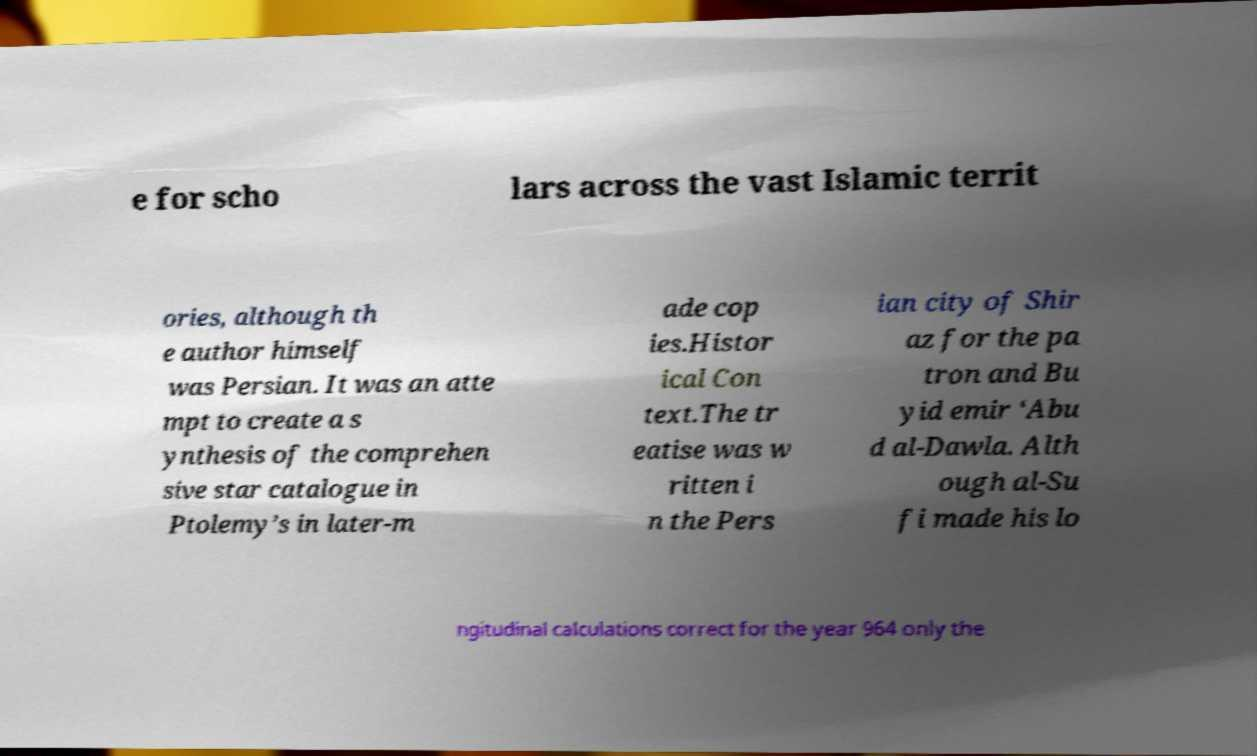There's text embedded in this image that I need extracted. Can you transcribe it verbatim? e for scho lars across the vast Islamic territ ories, although th e author himself was Persian. It was an atte mpt to create a s ynthesis of the comprehen sive star catalogue in Ptolemy’s in later-m ade cop ies.Histor ical Con text.The tr eatise was w ritten i n the Pers ian city of Shir az for the pa tron and Bu yid emir ‘Abu d al-Dawla. Alth ough al-Su fi made his lo ngitudinal calculations correct for the year 964 only the 